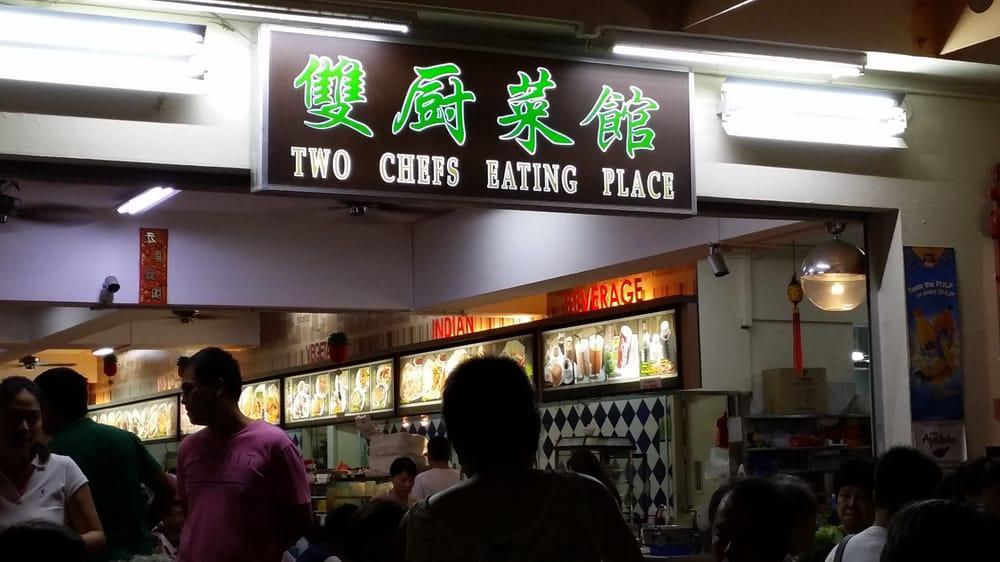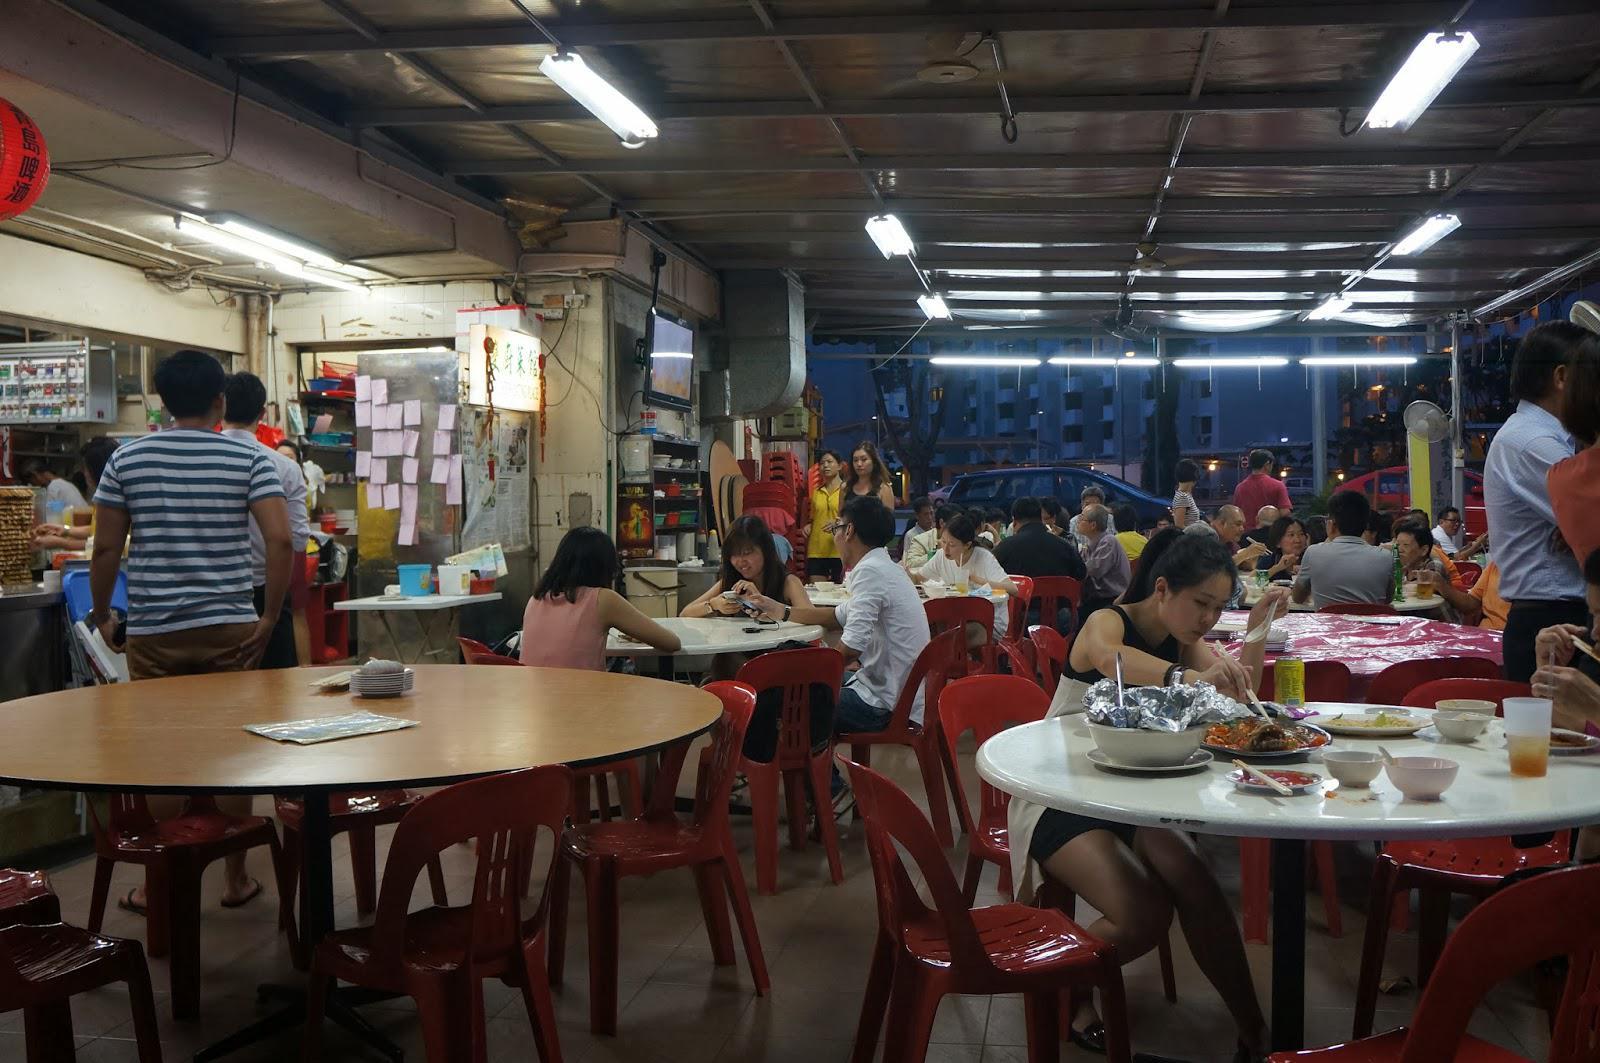The first image is the image on the left, the second image is the image on the right. Analyze the images presented: Is the assertion "IN at least one image there is greenery next to an outside cafe." valid? Answer yes or no. No. The first image is the image on the left, the second image is the image on the right. For the images displayed, is the sentence "An image shows a diner with green Chinese characters on a black rectangle at the top front, and a row of lighted horizontal rectangles above a diamond-tile pattern in the background." factually correct? Answer yes or no. Yes. 